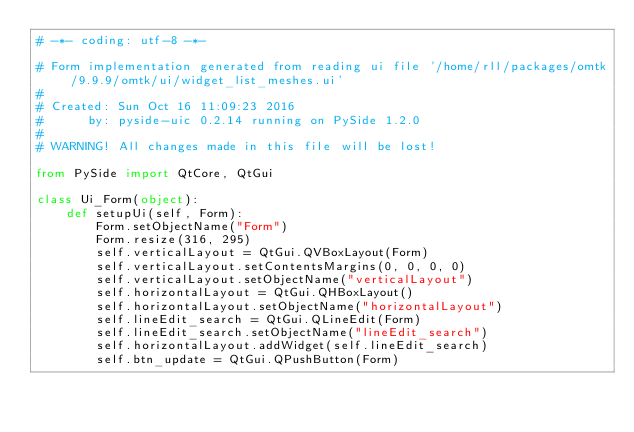<code> <loc_0><loc_0><loc_500><loc_500><_Python_># -*- coding: utf-8 -*-

# Form implementation generated from reading ui file '/home/rll/packages/omtk/9.9.9/omtk/ui/widget_list_meshes.ui'
#
# Created: Sun Oct 16 11:09:23 2016
#      by: pyside-uic 0.2.14 running on PySide 1.2.0
#
# WARNING! All changes made in this file will be lost!

from PySide import QtCore, QtGui

class Ui_Form(object):
    def setupUi(self, Form):
        Form.setObjectName("Form")
        Form.resize(316, 295)
        self.verticalLayout = QtGui.QVBoxLayout(Form)
        self.verticalLayout.setContentsMargins(0, 0, 0, 0)
        self.verticalLayout.setObjectName("verticalLayout")
        self.horizontalLayout = QtGui.QHBoxLayout()
        self.horizontalLayout.setObjectName("horizontalLayout")
        self.lineEdit_search = QtGui.QLineEdit(Form)
        self.lineEdit_search.setObjectName("lineEdit_search")
        self.horizontalLayout.addWidget(self.lineEdit_search)
        self.btn_update = QtGui.QPushButton(Form)</code> 